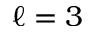<formula> <loc_0><loc_0><loc_500><loc_500>\ell = 3</formula> 